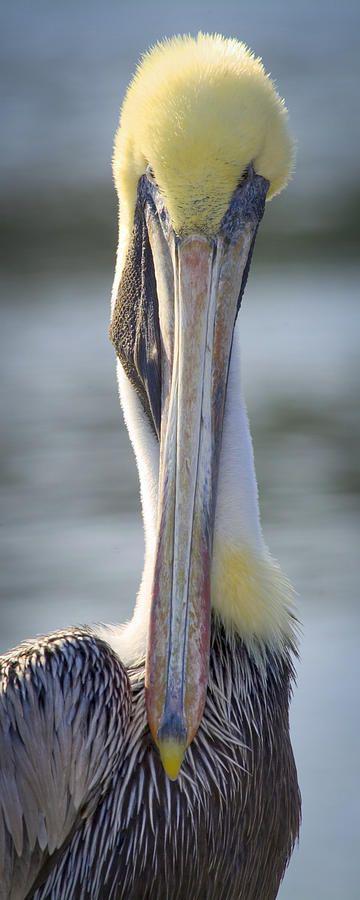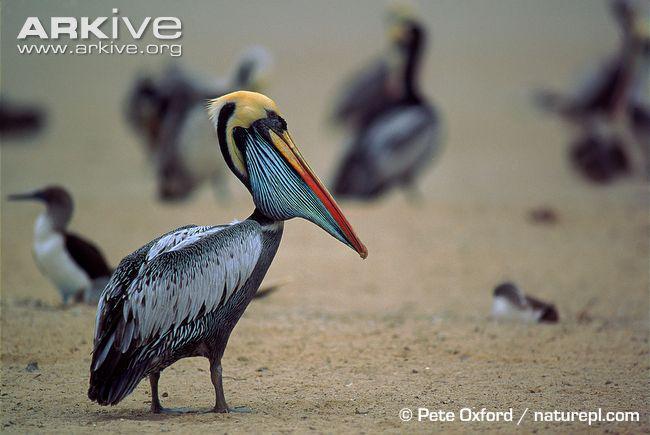The first image is the image on the left, the second image is the image on the right. Given the left and right images, does the statement "There is at least two birds in the left image." hold true? Answer yes or no. No. The first image is the image on the left, the second image is the image on the right. Assess this claim about the two images: "At least one image contains multiple pelicans in the foreground, and at least one image shows pelicans with their beaks crossed.". Correct or not? Answer yes or no. No. 